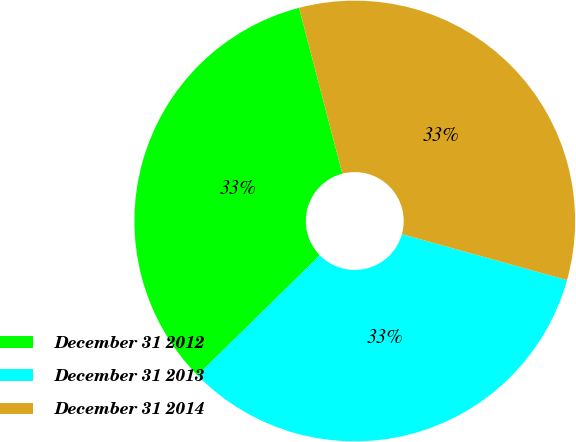<chart> <loc_0><loc_0><loc_500><loc_500><pie_chart><fcel>December 31 2012<fcel>December 31 2013<fcel>December 31 2014<nl><fcel>33.28%<fcel>33.33%<fcel>33.39%<nl></chart> 